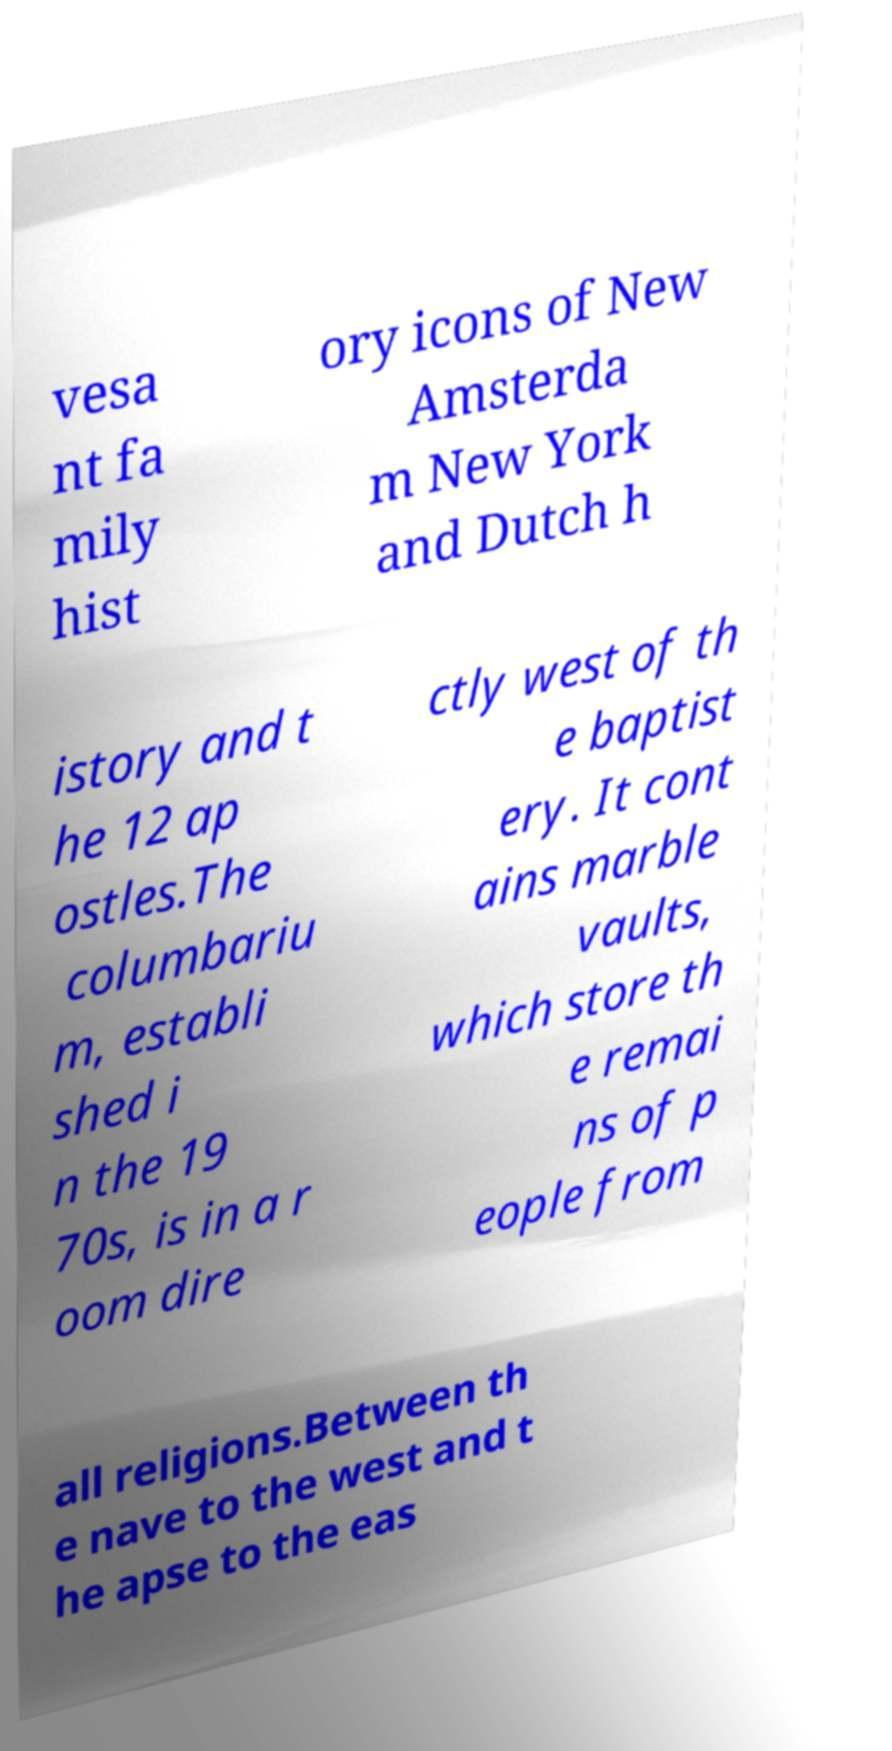Could you extract and type out the text from this image? vesa nt fa mily hist ory icons of New Amsterda m New York and Dutch h istory and t he 12 ap ostles.The columbariu m, establi shed i n the 19 70s, is in a r oom dire ctly west of th e baptist ery. It cont ains marble vaults, which store th e remai ns of p eople from all religions.Between th e nave to the west and t he apse to the eas 